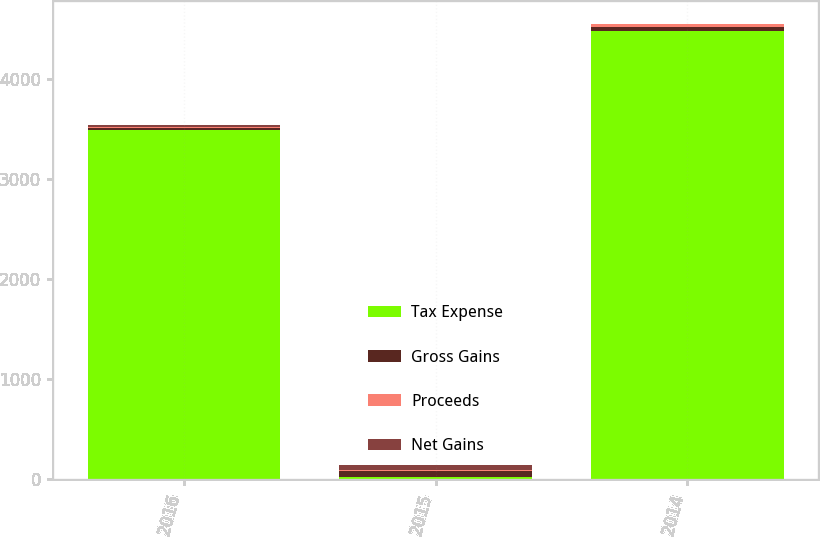Convert chart. <chart><loc_0><loc_0><loc_500><loc_500><stacked_bar_chart><ecel><fcel>2016<fcel>2015<fcel>2014<nl><fcel>Tax Expense<fcel>3489<fcel>29<fcel>4480<nl><fcel>Gross Gains<fcel>24<fcel>56<fcel>33<nl><fcel>Proceeds<fcel>8<fcel>13<fcel>29<nl><fcel>Net Gains<fcel>16<fcel>43<fcel>4<nl></chart> 